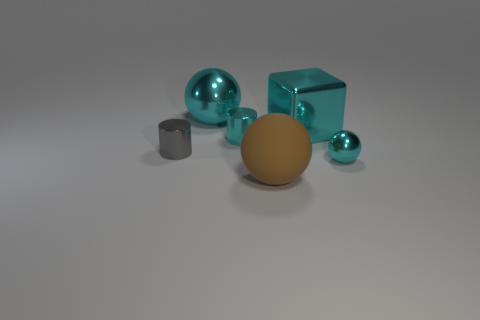Subtract all large cyan balls. How many balls are left? 2 Subtract 1 balls. How many balls are left? 2 Add 3 cyan metallic spheres. How many objects exist? 9 Subtract all cylinders. How many objects are left? 4 Subtract all cyan spheres. How many spheres are left? 1 Subtract 1 gray cylinders. How many objects are left? 5 Subtract all red cylinders. Subtract all blue balls. How many cylinders are left? 2 Subtract all purple cylinders. How many blue cubes are left? 0 Subtract all small gray things. Subtract all large yellow matte balls. How many objects are left? 5 Add 3 tiny cyan balls. How many tiny cyan balls are left? 4 